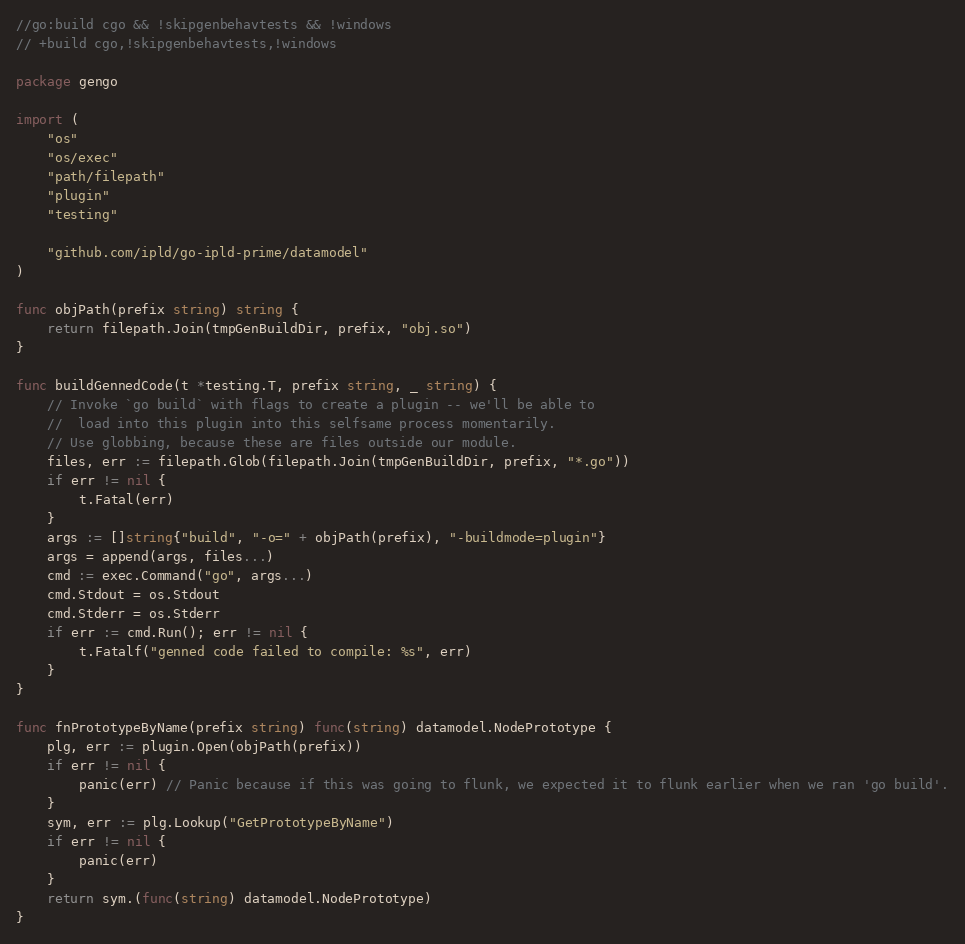Convert code to text. <code><loc_0><loc_0><loc_500><loc_500><_Go_>//go:build cgo && !skipgenbehavtests && !windows
// +build cgo,!skipgenbehavtests,!windows

package gengo

import (
	"os"
	"os/exec"
	"path/filepath"
	"plugin"
	"testing"

	"github.com/ipld/go-ipld-prime/datamodel"
)

func objPath(prefix string) string {
	return filepath.Join(tmpGenBuildDir, prefix, "obj.so")
}

func buildGennedCode(t *testing.T, prefix string, _ string) {
	// Invoke `go build` with flags to create a plugin -- we'll be able to
	//  load into this plugin into this selfsame process momentarily.
	// Use globbing, because these are files outside our module.
	files, err := filepath.Glob(filepath.Join(tmpGenBuildDir, prefix, "*.go"))
	if err != nil {
		t.Fatal(err)
	}
	args := []string{"build", "-o=" + objPath(prefix), "-buildmode=plugin"}
	args = append(args, files...)
	cmd := exec.Command("go", args...)
	cmd.Stdout = os.Stdout
	cmd.Stderr = os.Stderr
	if err := cmd.Run(); err != nil {
		t.Fatalf("genned code failed to compile: %s", err)
	}
}

func fnPrototypeByName(prefix string) func(string) datamodel.NodePrototype {
	plg, err := plugin.Open(objPath(prefix))
	if err != nil {
		panic(err) // Panic because if this was going to flunk, we expected it to flunk earlier when we ran 'go build'.
	}
	sym, err := plg.Lookup("GetPrototypeByName")
	if err != nil {
		panic(err)
	}
	return sym.(func(string) datamodel.NodePrototype)
}
</code> 